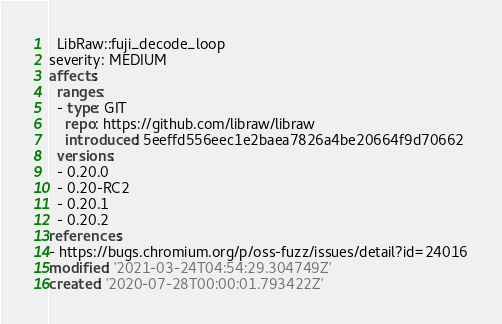<code> <loc_0><loc_0><loc_500><loc_500><_YAML_>  LibRaw::fuji_decode_loop
severity: MEDIUM
affects:
  ranges:
  - type: GIT
    repo: https://github.com/libraw/libraw
    introduced: 5eeffd556eec1e2baea7826a4be20664f9d70662
  versions:
  - 0.20.0
  - 0.20-RC2
  - 0.20.1
  - 0.20.2
references:
- https://bugs.chromium.org/p/oss-fuzz/issues/detail?id=24016
modified: '2021-03-24T04:54:29.304749Z'
created: '2020-07-28T00:00:01.793422Z'
</code> 